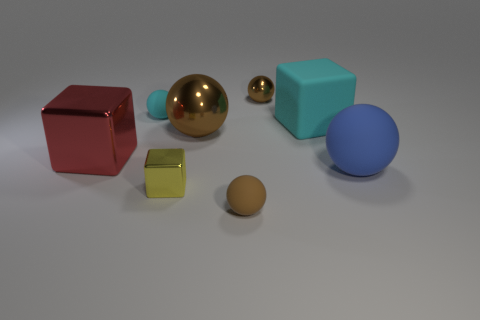Subtract all large cubes. How many cubes are left? 1 Add 1 big brown balls. How many objects exist? 9 Subtract 2 cubes. How many cubes are left? 1 Subtract all brown spheres. How many spheres are left? 2 Subtract all cubes. How many objects are left? 5 Subtract all gray cylinders. How many cyan spheres are left? 1 Subtract all big red metallic objects. Subtract all large purple shiny spheres. How many objects are left? 7 Add 2 brown matte balls. How many brown matte balls are left? 3 Add 4 tiny matte objects. How many tiny matte objects exist? 6 Subtract 0 purple blocks. How many objects are left? 8 